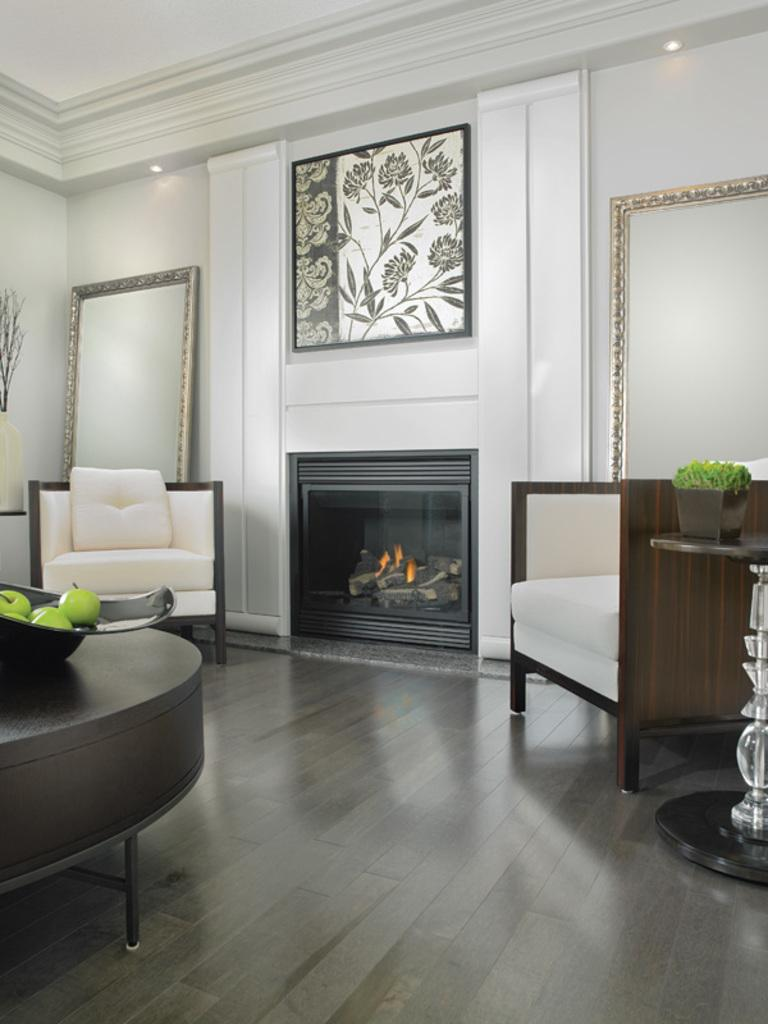How many couches are visible in the image? There are 2 couches in the image. What is on the table in the image? There is a table with fruits on it in the image. What can be seen in the background of the image? There is a mirror, a wall, and a fireplace in the background of the image. What type of ray is swimming in the fireplace in the image? There is no ray present in the image, and the fireplace is not a body of water where a ray could swim. 